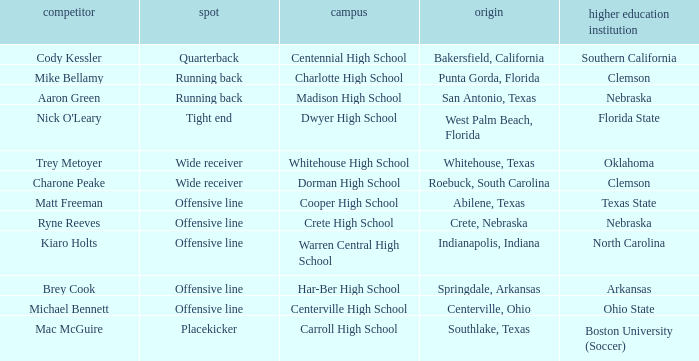What college did Matt Freeman go to? Texas State. 